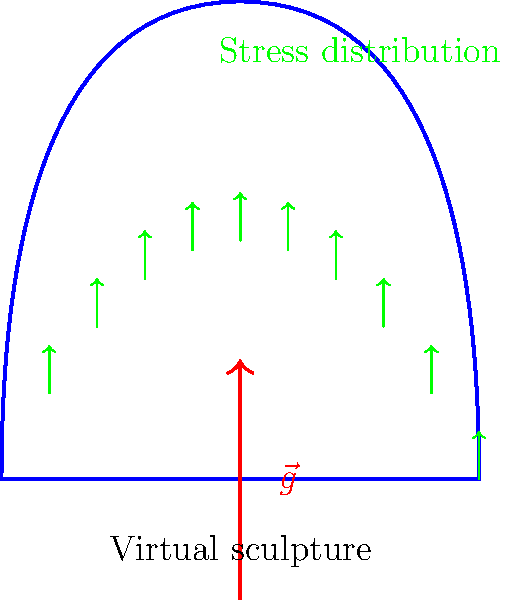In the virtual reality sculpture shown above, which is subjected to simulated gravity $\vec{g}$, how would you expect the stress distribution to vary along the curved surface? Consider the sculpture's shape and the direction of the gravity vector. To determine the stress distribution on the virtual sculpture, we need to consider several factors:

1. Shape of the sculpture: The sculpture has a curved surface that rises from the base and then descends.

2. Direction of gravity: The gravity vector $\vec{g}$ is pointing downward.

3. Stress distribution principles:
   a. Stress is typically higher in areas where the material is supporting more weight.
   b. Curved surfaces can lead to stress concentrations.

Step-by-step analysis:

1. At the base (x = 0 and x = 2):
   - Stress will be highest due to supporting the entire weight of the structure above.
   - The stress here will be primarily compressive.

2. Moving up the left side (0 < x < 1):
   - Stress decreases as we move upward because there's less material above to support.
   - The curve creates a slight stress concentration.

3. At the peak (x ≈ 1):
   - Stress reaches a local minimum as it's supporting the least amount of material.
   - There may be a small amount of tensile stress on the top surface due to bending.

4. Moving down the right side (1 < x < 2):
   - Stress increases again as we move downward.
   - The curvature creates another stress concentration.

5. Overall distribution:
   - The stress vectors (shown in green) are larger at the base and smaller at the top, indicating higher stress at the bottom.
   - The distribution is roughly symmetrical due to the symmetry of the sculpture.

In a virtual reality environment, this stress distribution could be visualized using color gradients or vector fields, allowing the sculptor to identify areas of high stress that might need reinforcement in a physical realization of the sculpture.
Answer: Highest at the base, decreasing towards the peak, with concentrations along curved surfaces. 